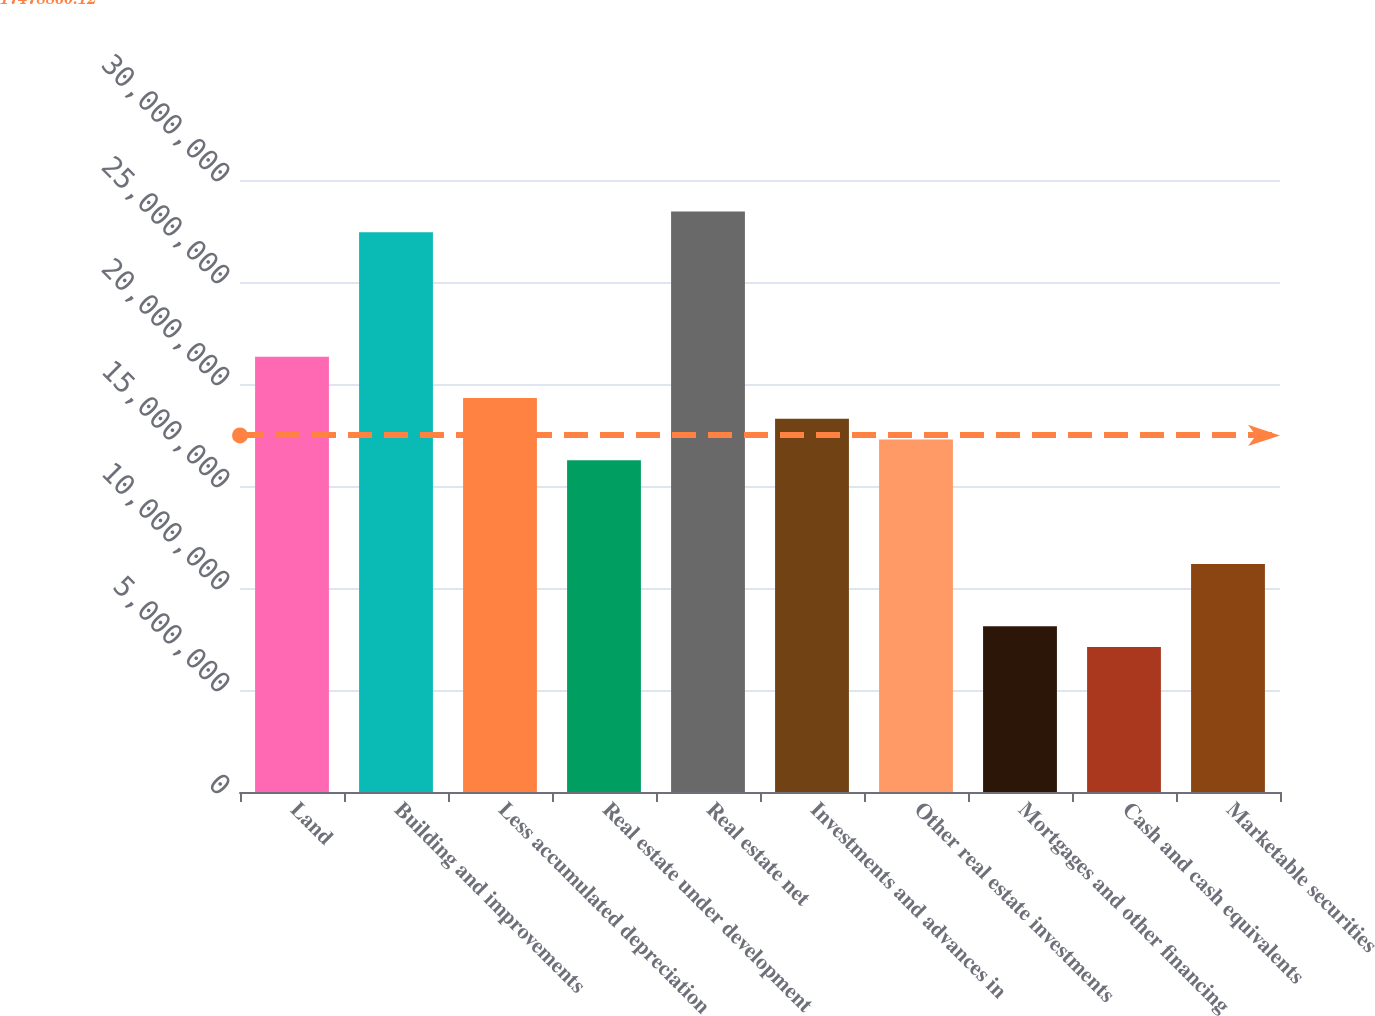<chart> <loc_0><loc_0><loc_500><loc_500><bar_chart><fcel>Land<fcel>Building and improvements<fcel>Less accumulated depreciation<fcel>Real estate under development<fcel>Real estate net<fcel>Investments and advances in<fcel>Other real estate investments<fcel>Mortgages and other financing<fcel>Cash and cash equivalents<fcel>Marketable securities<nl><fcel>2.13404e+07<fcel>2.74376e+07<fcel>1.9308e+07<fcel>1.62594e+07<fcel>2.84538e+07<fcel>1.82918e+07<fcel>1.72756e+07<fcel>8.1298e+06<fcel>7.1136e+06<fcel>1.11784e+07<nl></chart> 